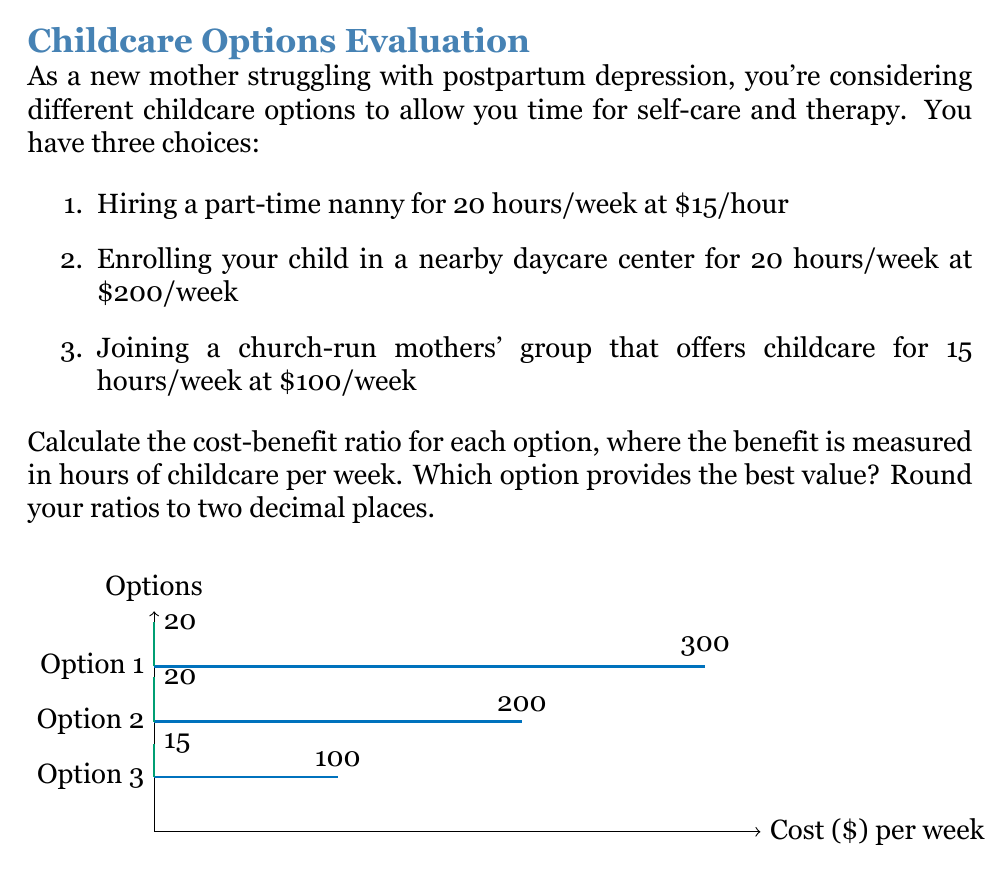Can you answer this question? To solve this problem, we need to calculate the cost-benefit ratio for each option. The cost-benefit ratio is calculated as:

$$ \text{Cost-Benefit Ratio} = \frac{\text{Cost}}{\text{Benefit}} $$

Where cost is in dollars per week, and benefit is in hours of childcare per week.

For each option:

1. Part-time nanny:
   Cost = $15/hour * 20 hours = $300/week
   Benefit = 20 hours/week
   Ratio = $\frac{300}{20} = 15$

2. Daycare center:
   Cost = $200/week
   Benefit = 20 hours/week
   Ratio = $\frac{200}{20} = 10$

3. Church-run mothers' group:
   Cost = $100/week
   Benefit = 15 hours/week
   Ratio = $\frac{100}{15} = 6.67$

Rounding to two decimal places:
1. Nanny: 15.00
2. Daycare: 10.00
3. Church group: 6.67

The lower the ratio, the better the value. Therefore, the church-run mothers' group provides the best value, as it has the lowest cost-benefit ratio of 6.67.
Answer: Church-run mothers' group (ratio: 6.67) 